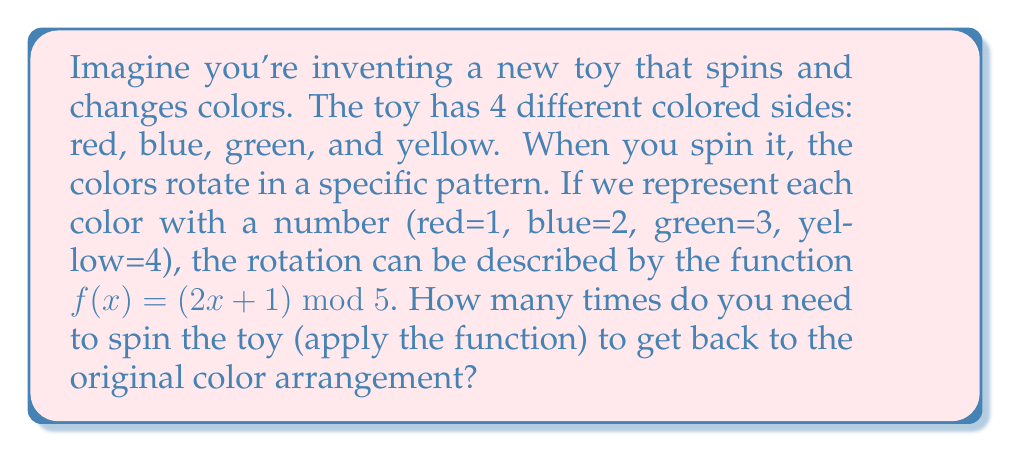Give your solution to this math problem. Let's approach this step-by-step:

1) First, we need to understand what the function does. For each color (represented by a number), it:
   - Multiplies the number by 2
   - Adds 1
   - Takes the result modulo 5

2) Let's see what happens when we apply this function repeatedly:

   Starting with red (1):
   $f(1) = (2(1) + 1) \bmod 5 = 3 \bmod 5 = 3$ (green)
   $f(3) = (2(3) + 1) \bmod 5 = 7 \bmod 5 = 2$ (blue)
   $f(2) = (2(2) + 1) \bmod 5 = 5 \bmod 5 = 0$ (which we interpret as 4, yellow)
   $f(4) = (2(4) + 1) \bmod 5 = 9 \bmod 5 = 4$ (yellow)
   $f(4) = (2(4) + 1) \bmod 5 = 9 \bmod 5 = 4$ (yellow)

3) We see that after 4 applications of the function, we reach a fixed point (yellow).

4) To complete the cycle and return to the original arrangement, we need one more application:
   $f(4) = (2(4) + 1) \bmod 5 = 9 \bmod 5 = 4$ (yellow)
   $f(4) = (2(4) + 1) \bmod 5 = 9 \bmod 5 = 4$ (yellow)
   ...
   $f(4) = (2(4) + 1) \bmod 5 = 9 \bmod 5 = 4$ (yellow)
   $f(4) = (2(4) + 1) \bmod 5 = 9 \bmod 5 = 4$ (yellow)
   $f(4) = (2(4) + 1) \bmod 5 = 9 \bmod 5 = 4$ (yellow)
   $f(4) = (2(4) + 1) \bmod 5 = 9 \bmod 5 = 4$ (yellow)

5) This continues indefinitely. The toy will never return to its original arrangement.

This is an example of a function that does not have a full cycle. Instead, it has a partial cycle (red → green → blue → yellow) and then a fixed point (yellow).
Answer: The toy will never return to its original color arrangement. After 4 spins, it reaches a fixed point (yellow) and stays there indefinitely. 